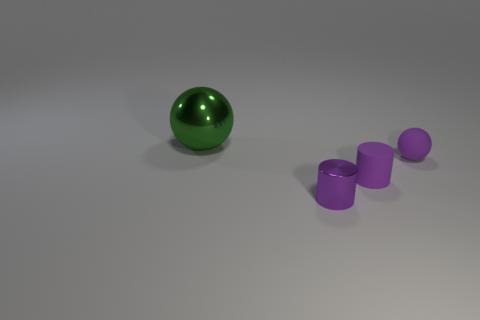Add 3 rubber cylinders. How many objects exist? 7 Add 4 tiny purple metal cylinders. How many tiny purple metal cylinders are left? 5 Add 1 small purple shiny cubes. How many small purple shiny cubes exist? 1 Subtract 0 gray spheres. How many objects are left? 4 Subtract all big green balls. Subtract all large cubes. How many objects are left? 3 